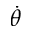Convert formula to latex. <formula><loc_0><loc_0><loc_500><loc_500>\dot { \theta }</formula> 